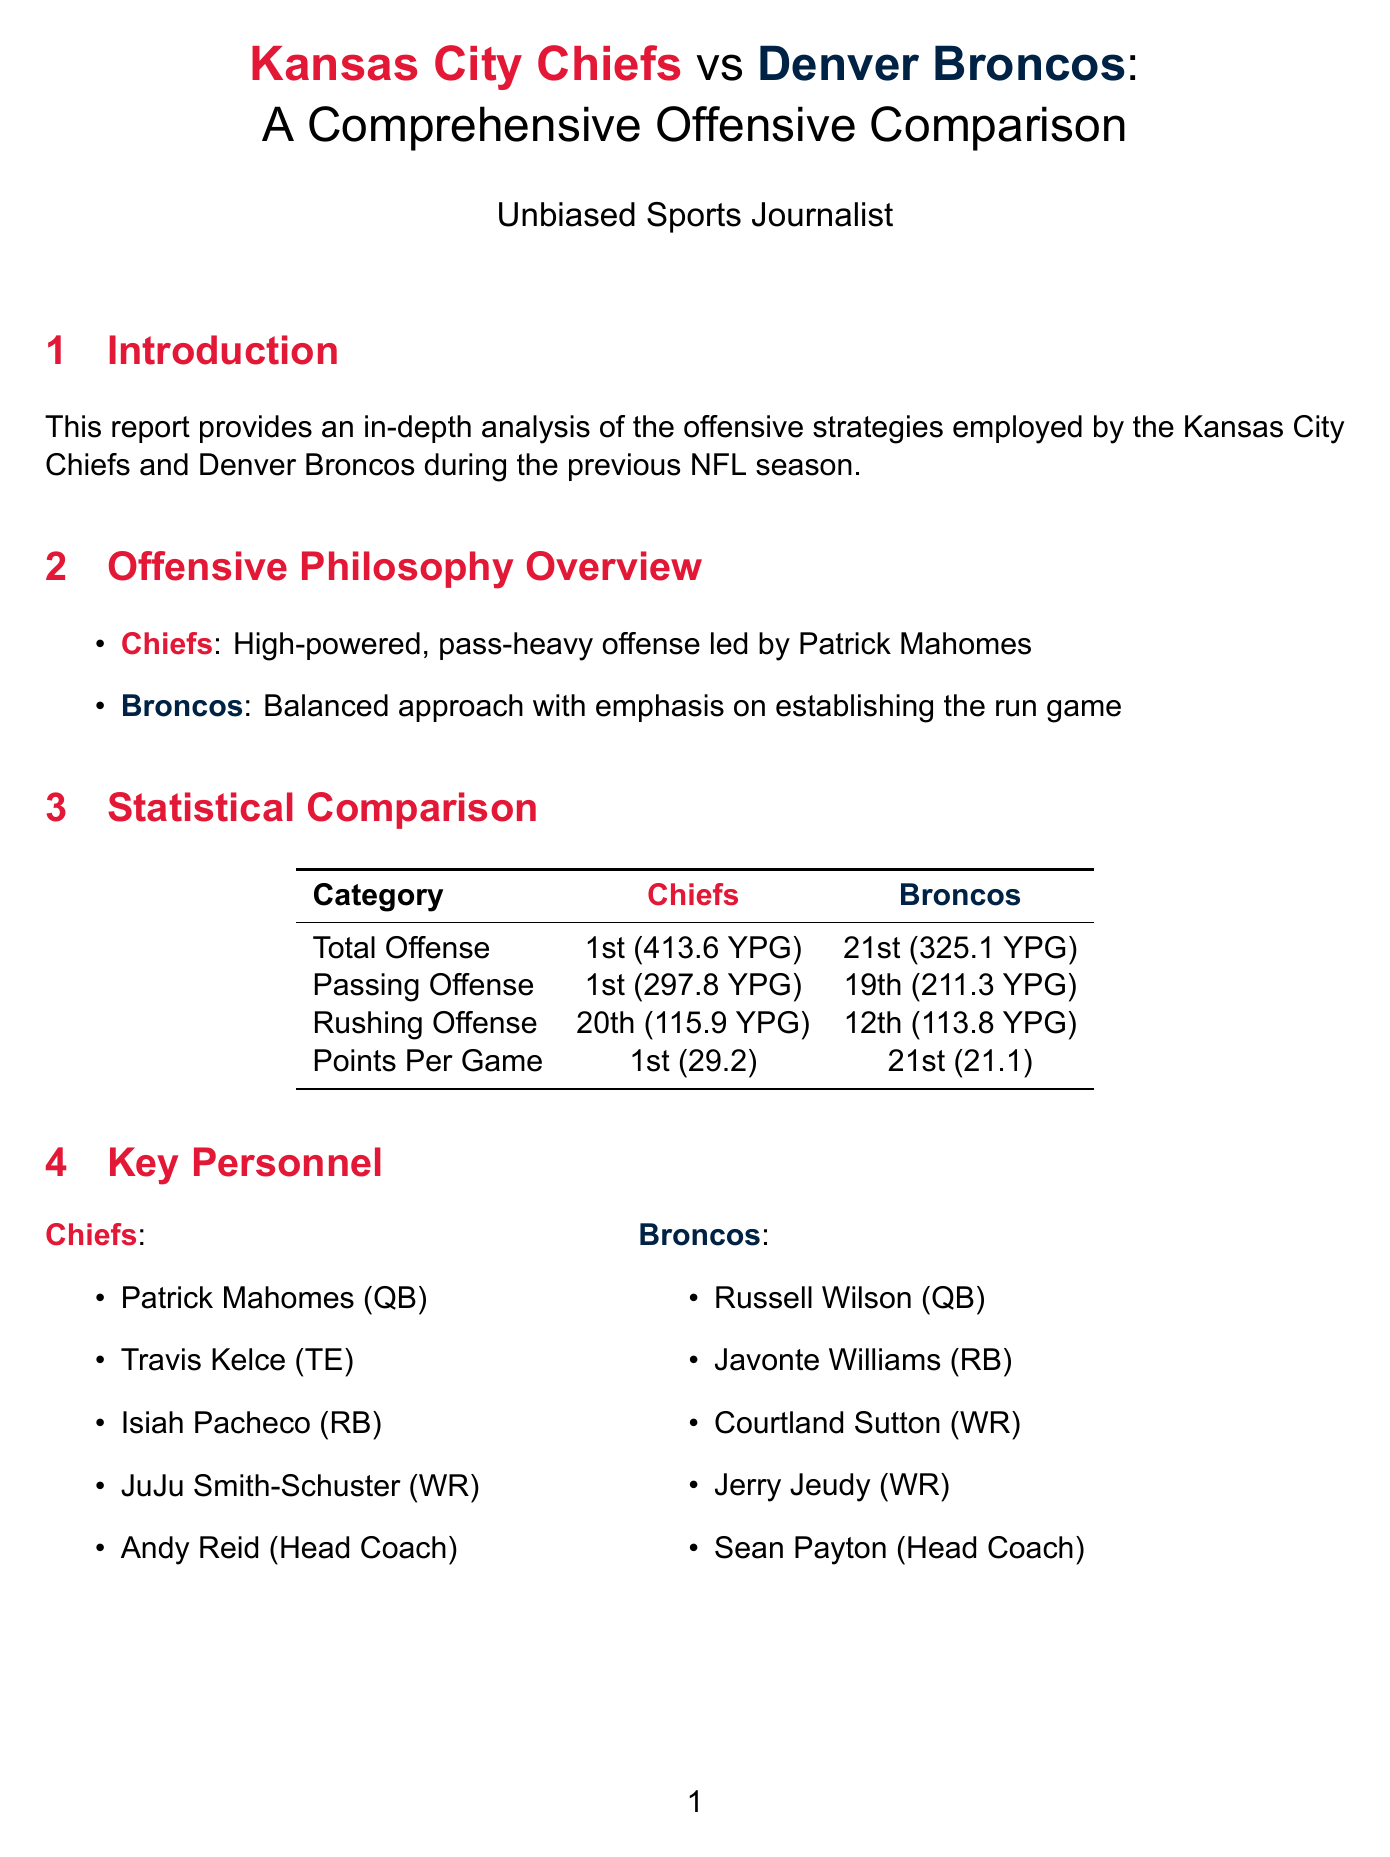What is the Chiefs' rank in total offense? The Chiefs rank 1st in total offense, indicating their dominance in yardage gained per game.
Answer: 1st What was the Broncos' points per game last season? The document states that the Broncos averaged 21.1 points per game, which reflects their scoring performance.
Answer: 21.1 Who is the Head Coach of the Chiefs? The report identifies Andy Reid as the Head Coach of the Chiefs, highlighting his role in the team's offensive strategy.
Answer: Andy Reid What is the red zone efficiency percentage for the Chiefs? The Chiefs' red zone efficiency is provided in the document, showcasing their effectiveness in scoring opportunities inside the opponent's 20-yard line.
Answer: 71.08% What is a key offensive trend for the Broncos? The document lists several trends for the Broncos, one of which includes utilizing Russell Wilson's mobility on designed rollouts, illustrating their offensive strategy.
Answer: Utilizing Russell Wilson's mobility on designed rollouts How do the Chiefs rank in third down conversion percentage? The Chiefs' rank in third down conversion is 2nd, indicating their success in maintaining drives during critical situations.
Answer: 2nd What was the key play for the Broncos against the Raiders? The reported key play highlights Wilson's touchdown pass in overtime, which represents a crucial moment in the game.
Answer: Wilson 11-yard TD pass to Kendall Hinton in overtime What is the Chiefs' rushing offense rank? The Chiefs are ranked 20th in rushing offense, showing that while they excel in passing, their ground game is less emphasized.
Answer: 20th What is the passing offense rank of the Broncos? The report shows that the Broncos ranked 19th in passing offense, indicating their challenges in this area.
Answer: 19th 